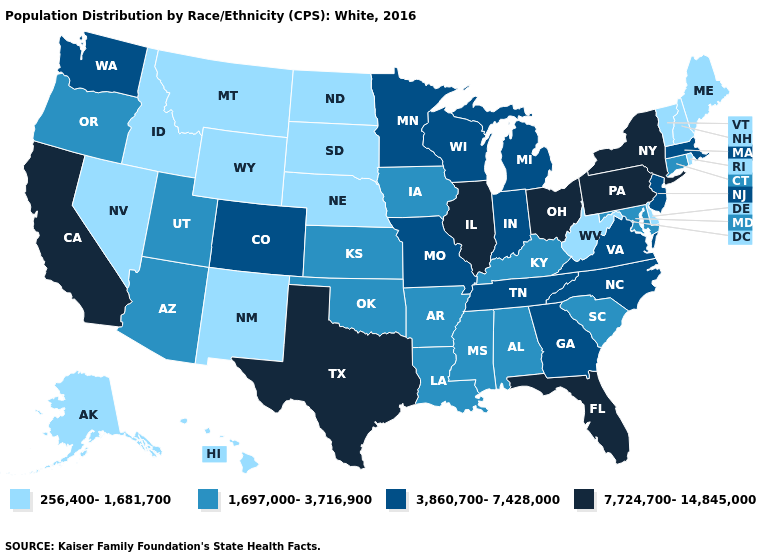Which states have the lowest value in the USA?
Short answer required. Alaska, Delaware, Hawaii, Idaho, Maine, Montana, Nebraska, Nevada, New Hampshire, New Mexico, North Dakota, Rhode Island, South Dakota, Vermont, West Virginia, Wyoming. Among the states that border Florida , which have the highest value?
Quick response, please. Georgia. Does the map have missing data?
Write a very short answer. No. What is the value of Minnesota?
Give a very brief answer. 3,860,700-7,428,000. Name the states that have a value in the range 7,724,700-14,845,000?
Keep it brief. California, Florida, Illinois, New York, Ohio, Pennsylvania, Texas. Which states have the lowest value in the USA?
Quick response, please. Alaska, Delaware, Hawaii, Idaho, Maine, Montana, Nebraska, Nevada, New Hampshire, New Mexico, North Dakota, Rhode Island, South Dakota, Vermont, West Virginia, Wyoming. What is the value of Nebraska?
Short answer required. 256,400-1,681,700. Name the states that have a value in the range 1,697,000-3,716,900?
Keep it brief. Alabama, Arizona, Arkansas, Connecticut, Iowa, Kansas, Kentucky, Louisiana, Maryland, Mississippi, Oklahoma, Oregon, South Carolina, Utah. What is the lowest value in states that border New Jersey?
Concise answer only. 256,400-1,681,700. Which states have the lowest value in the USA?
Be succinct. Alaska, Delaware, Hawaii, Idaho, Maine, Montana, Nebraska, Nevada, New Hampshire, New Mexico, North Dakota, Rhode Island, South Dakota, Vermont, West Virginia, Wyoming. Does Arizona have a lower value than Indiana?
Answer briefly. Yes. Does Texas have the highest value in the USA?
Give a very brief answer. Yes. Which states have the lowest value in the South?
Answer briefly. Delaware, West Virginia. Is the legend a continuous bar?
Write a very short answer. No. Name the states that have a value in the range 1,697,000-3,716,900?
Answer briefly. Alabama, Arizona, Arkansas, Connecticut, Iowa, Kansas, Kentucky, Louisiana, Maryland, Mississippi, Oklahoma, Oregon, South Carolina, Utah. 